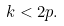<formula> <loc_0><loc_0><loc_500><loc_500>k < 2 p .</formula> 